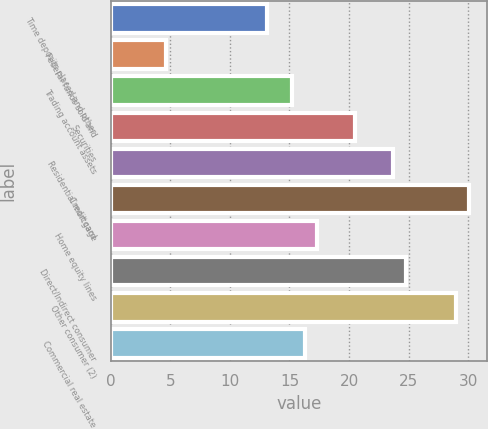Convert chart. <chart><loc_0><loc_0><loc_500><loc_500><bar_chart><fcel>Time deposits placed and other<fcel>Federal funds sold and<fcel>Trading account assets<fcel>Securities<fcel>Residential mortgage<fcel>Credit card<fcel>Home equity lines<fcel>Direct/Indirect consumer<fcel>Other consumer (2)<fcel>Commercial real estate<nl><fcel>13.1<fcel>4.62<fcel>15.22<fcel>20.52<fcel>23.7<fcel>30.06<fcel>17.34<fcel>24.76<fcel>29<fcel>16.28<nl></chart> 